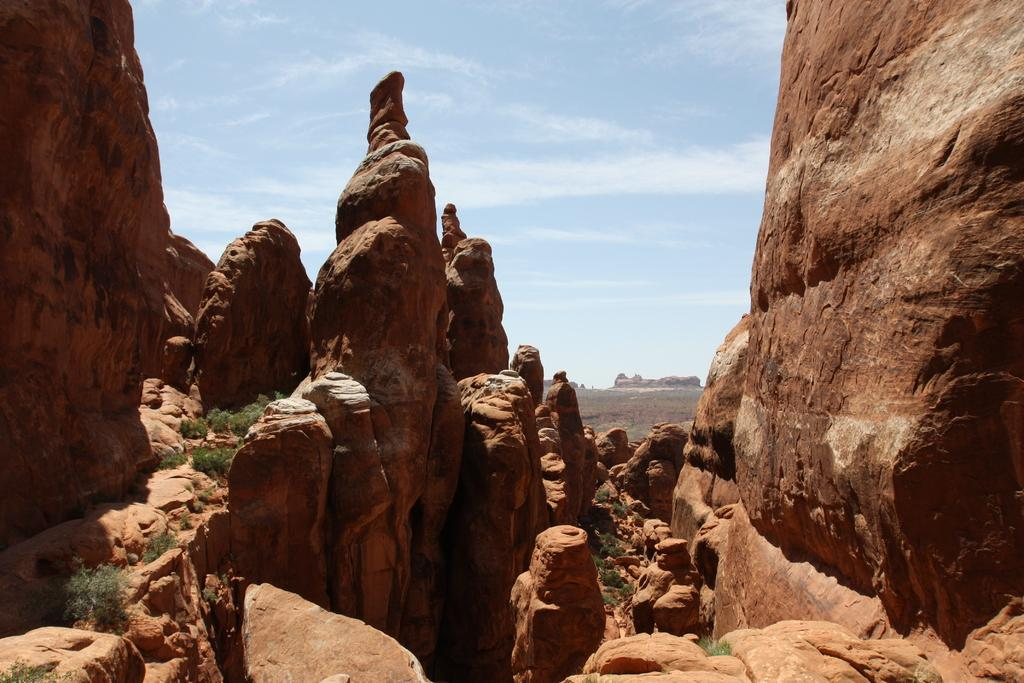What is the primary subject of the image? There are many books in the image. What type of natural environment is visible in the image? There is grass visible in the image. What is visible at the top of the image? The sky is visible at the top of the image. What type of shoes can be seen on the books in the image? There are no shoes present in the image; it features books and a natural environment. 